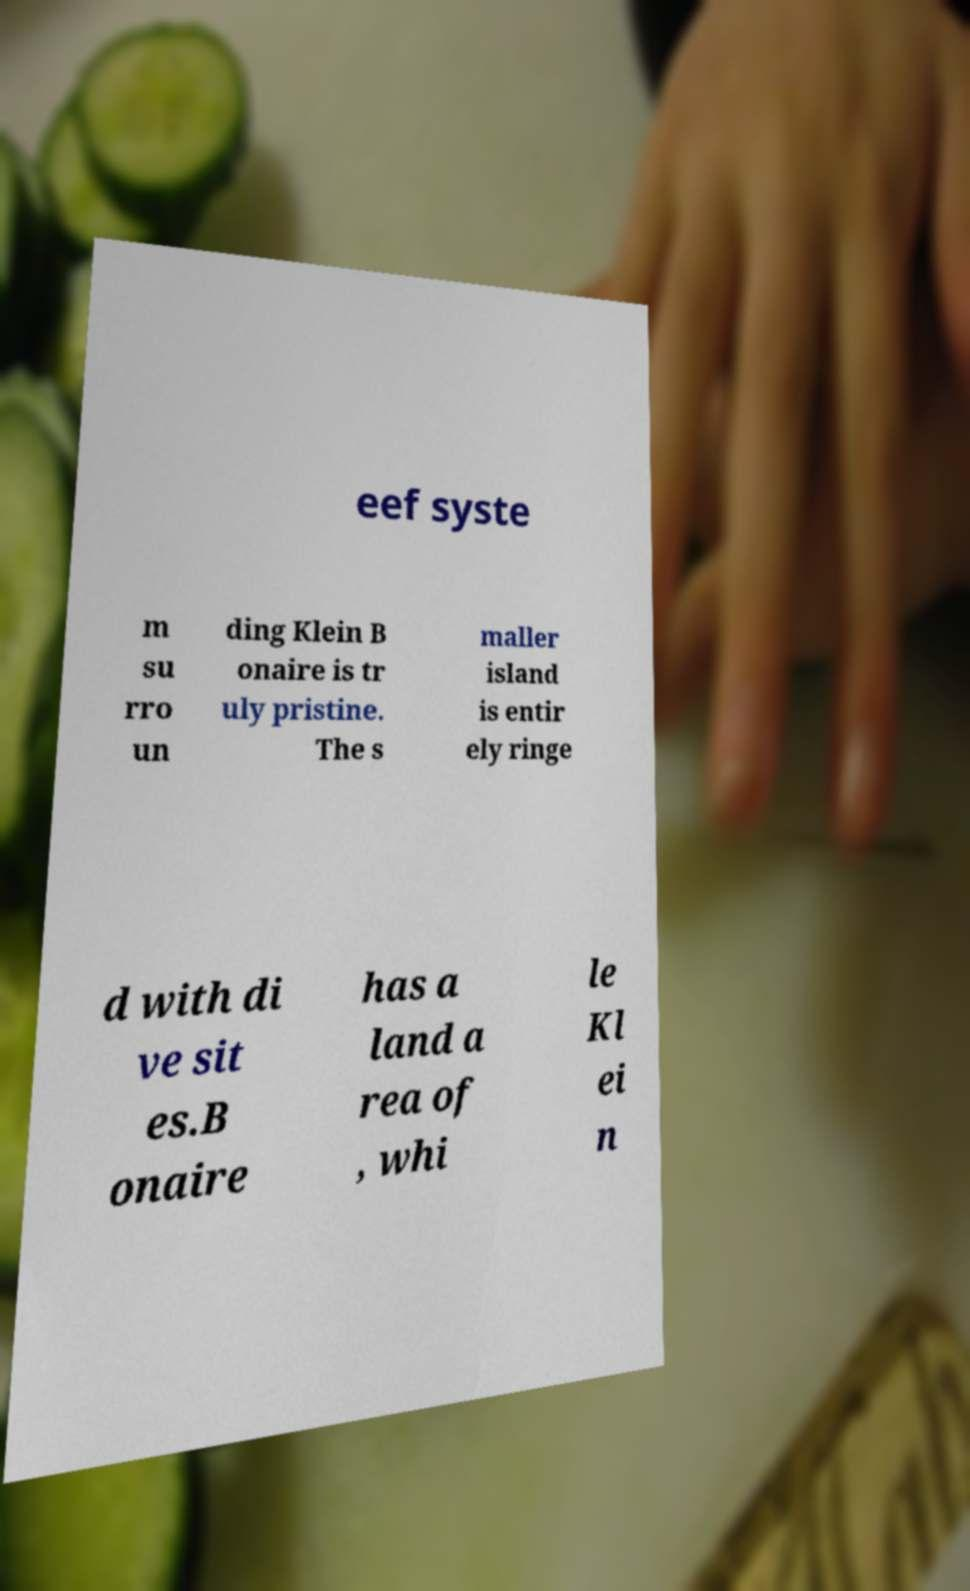What messages or text are displayed in this image? I need them in a readable, typed format. eef syste m su rro un ding Klein B onaire is tr uly pristine. The s maller island is entir ely ringe d with di ve sit es.B onaire has a land a rea of , whi le Kl ei n 